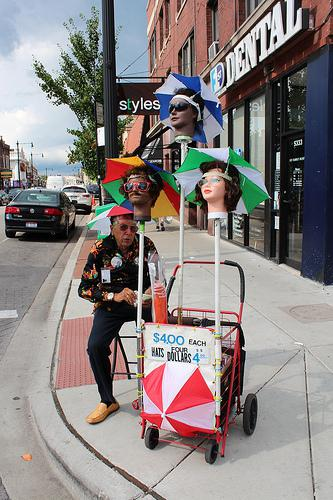Question: where is this picture taken?
Choices:
A. On the beach.
B. By a mountain.
C. On the sidewalk.
D. In the city.
Answer with the letter. Answer: C Question: what does the man use for selling?
Choices:
A. A store.
B. A push cart.
C. A car.
D. A stand.
Answer with the letter. Answer: B Question: how is the man positioned?
Choices:
A. He is leaning.
B. He is laying down.
C. The man is sitting.
D. He is reclining.
Answer with the letter. Answer: C Question: who is the man with?
Choices:
A. With two ladies.
B. With his friend.
C. All alone by himself.
D. With a child.
Answer with the letter. Answer: C 